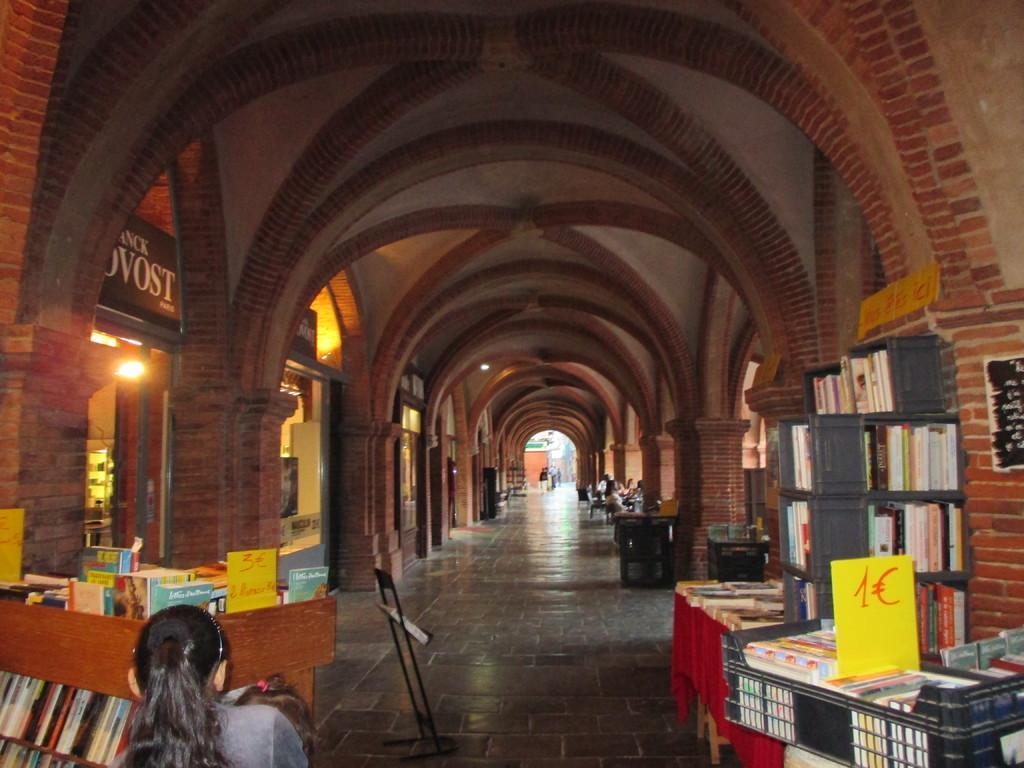Describe this image in one or two sentences. In the picture I can see the books on the wooden shelves. There are books in the plastic storage container, which is on the bottom right side. I can see a woman on the bottom left side. I can see a few persons sitting on the chairs on the right side and there are a few persons walking on the floor. In the picture I can see the arch design constructions. 